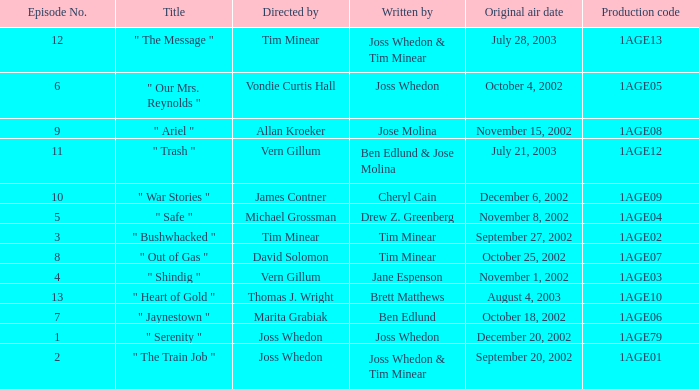What is the production code for the episode written by Drew Z. Greenberg? 1AGE04. 